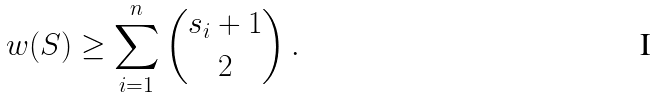<formula> <loc_0><loc_0><loc_500><loc_500>w ( S ) \geq \sum _ { i = 1 } ^ { n } { { s _ { i } + 1 } \choose 2 } \, .</formula> 